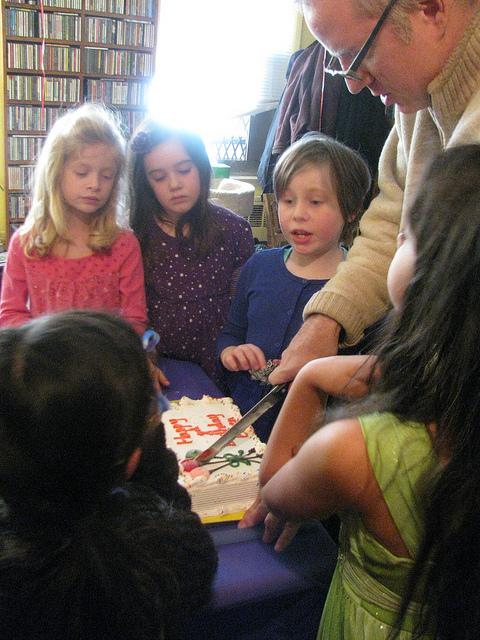What is the man holding?
Answer briefly. Knife. What is the likely relation here?
Answer briefly. Friends. How many children in the photo?
Answer briefly. 5. Is this a library?
Be succinct. Yes. What shape is on the girl's shirt?
Write a very short answer. Dots. What is the mood of the girl in blue?
Short answer required. Happy. Who is cutting the cake?
Concise answer only. Man. Does this little girl have a helmet?
Quick response, please. No. What is the man doing?
Concise answer only. Cutting cake. What is the young lady doing?
Concise answer only. Looking. What are they eating?
Keep it brief. Cake. 